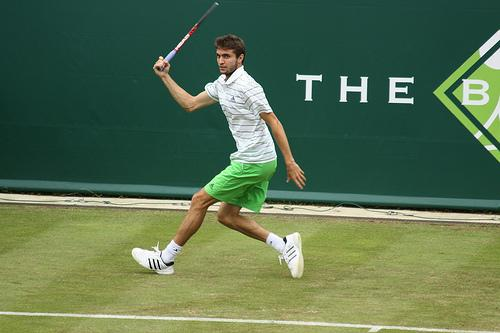Specify an anomaly in the image, if any. A man holding a pole is depicted in the image, but it is unclear how it relates to the tennis scene. Describe the physical appearance of the man playing tennis, such as his hair, facial hair, and skin color. The man playing tennis has short brown hair, facial hair, and appears to be Caucasian. What is unique about the tennis player's outfit? Specify the color and patterns of his clothing. The tennis player is wearing light green shorts and a striped white t-shirt. What is written on the green wall near the tennis court? The word "the" is written on the green wall near the tennis court. Analyze the context of the image based on the captions provided. The image shows a man playing tennis on a grassy court, with various details about his clothing and surroundings, such as the green wall with words and a sign nearby. Identify the sport the man is playing and describe the condition of the court. The man is playing tennis, and the court is a grassy surface marked with white lines. What is the color of the tennis racket handle and which hand is the man holding it in? The tennis racket handle is blue, and the man is holding it in his left hand. What kind of sign is present in the image, and what is its placement in relation to the tennis court? A green and white sign is present near the tennis court with words on it. What color are the sneakers the man is wearing, and which brand logo can be seen on his socks? The man is wearing white sneakers with blue stripes, and there is a brand logo on his white socks. Explain the position and movement of the tennis player in the image. The tennis player is in motion, with his arm up and leg bent, holding a racket in his left hand. What color is the tennis racket handle? Blue What is located near the tennis court? Words on a green wall Can you see a brand logo on the shorts or socks? Yes, on both Are the white lines on the ground a part of the tennis court? Yes Is the man wearing blue jeans and a white t-shirt in the image? The man in the image is wearing green shorts and a striped shirt, not blue jeans and a white t-shirt. The instruction is misleading because it suggests that the man is wearing different clothing than what is depicted in the image. What type of facial hair does the man have? None What is the hairstyle of the man? Short brown hair Describe the scene involving the man and the tennis court. A man playing tennis on a grassy tennis court with green shorts and a striped shirt. Is there a black and white striped flag near the tennis court? There is no striped flag in the image, only a green and white sign. The instruction is misleading because it describes an object that is not present in the image. What is the color of the boundary line on the tennis court? White What does the elbow position of the man suggest? He is in motion Is the man's hand holding the tennis racket empty or full? Full What color are the shorts the man is wearing? Green Choose the correct description of the man's shoes: (1) Pink sneakers with yellow stripes, (2) White and black tennis shoes, (3) Green sandals with red polka dots. (2) White and black tennis shoes What is written on the green wall? The word "the" Is the man playing basketball in the image? The man is actually playing tennis, not basketball. The instruction is misleading because it suggests that the image depicts a different sport. Identify the type of tennis court in the image. Grassy tennis court What color are the man's sneakers? White with blue stripes Does the man have long, curly blonde hair? The man in the image has short brown hair, not long blonde hair. The instruction is misleading because it inaccurately describes the man's hair. What part of the man is bent? His legs and elbow What is the man in the image doing? Playing tennis Can you see a soccer ball on the grass in the image? There is no soccer ball in the image, only a grassy tennis court. The instruction is misleading because it suggests an object in the image that doesn't exist. Is the sign on the wall red and contains the word "Stop?" The sign in the image is actually green and white, and the word on the wall is "the." The instruction is misleading because it provides incorrect information about the color and content of the sign. Describe the pattern on the man's shirt. Striped 